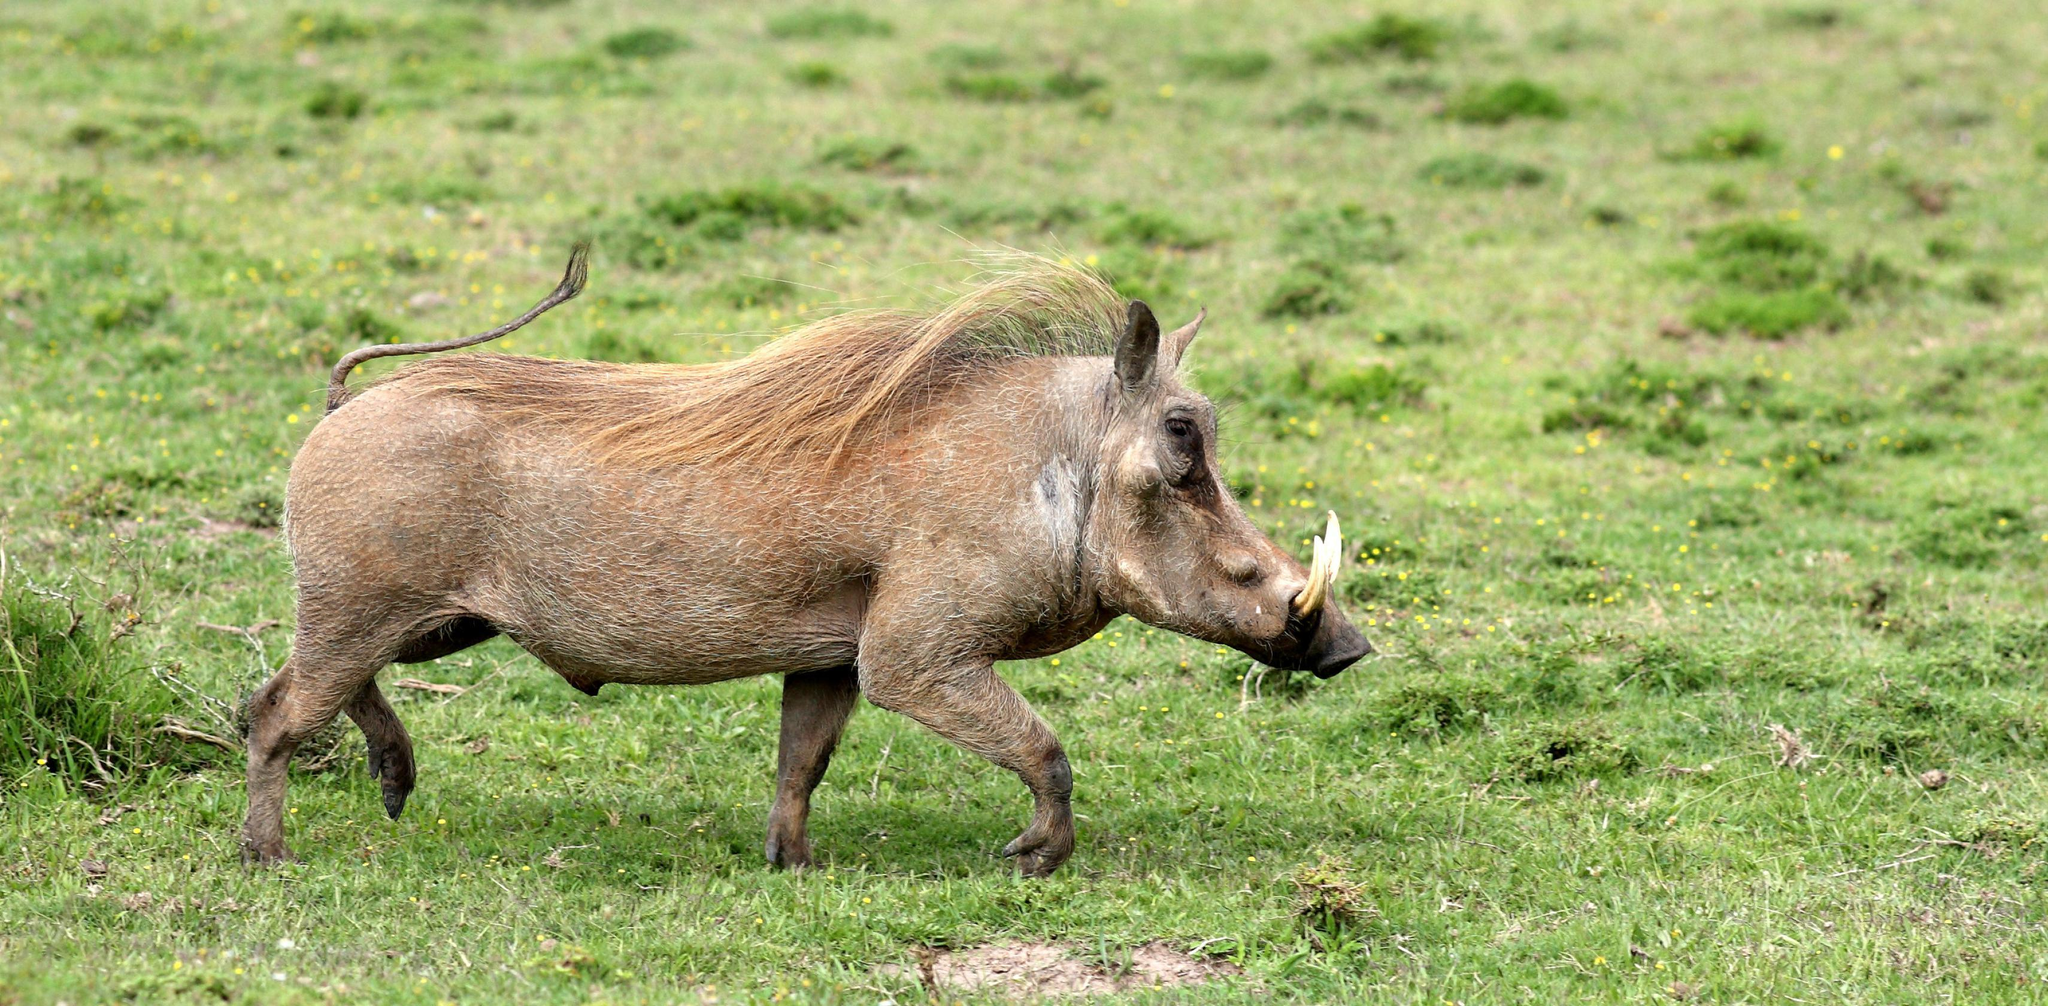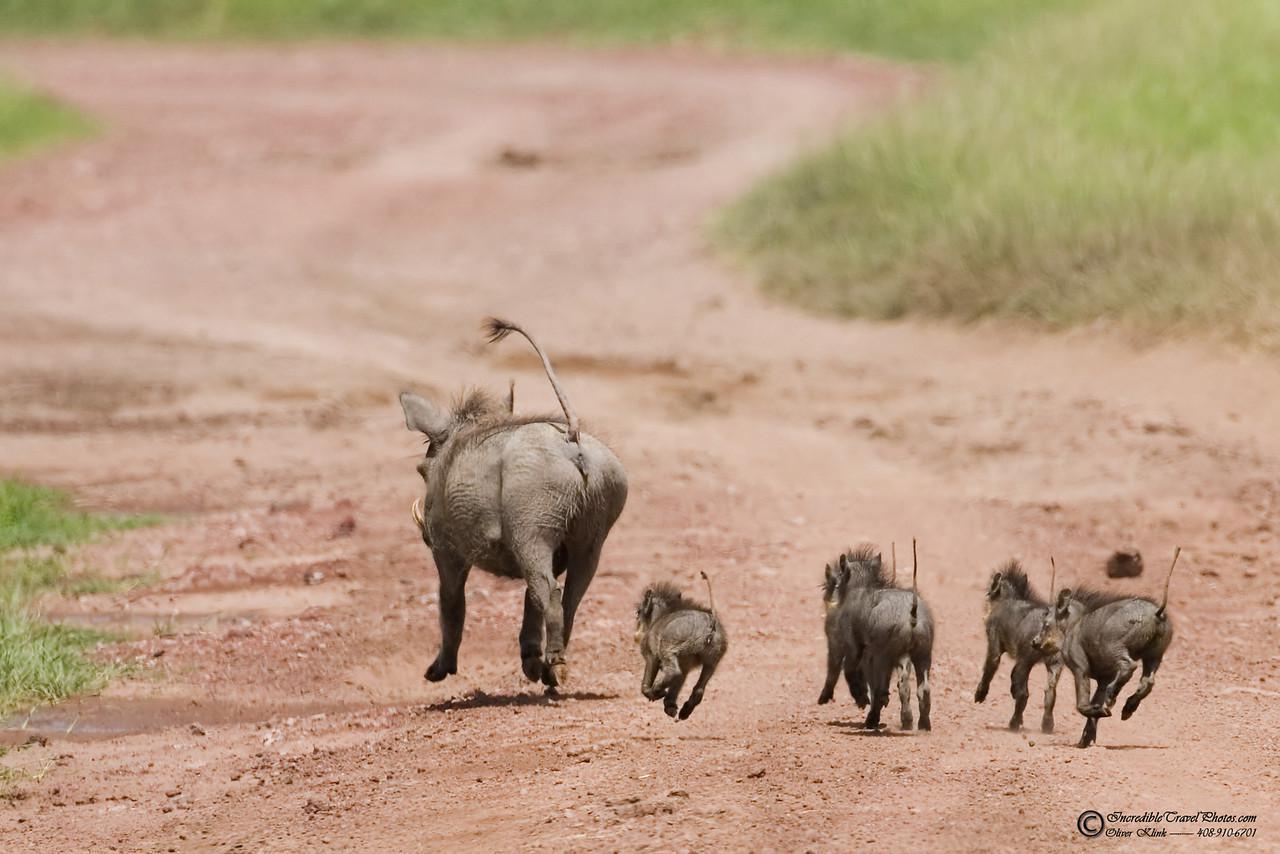The first image is the image on the left, the second image is the image on the right. For the images displayed, is the sentence "One of the images has only one wart hog with two tusks." factually correct? Answer yes or no. Yes. The first image is the image on the left, the second image is the image on the right. Evaluate the accuracy of this statement regarding the images: "There at least one lone animal that has large tusks.". Is it true? Answer yes or no. Yes. 